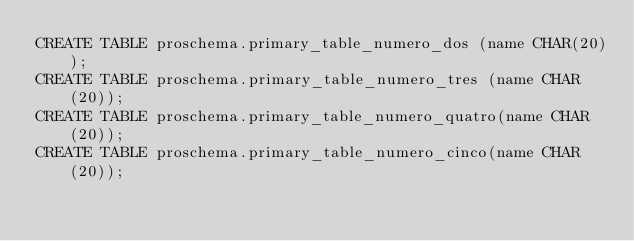<code> <loc_0><loc_0><loc_500><loc_500><_SQL_>CREATE TABLE proschema.primary_table_numero_dos (name CHAR(20));
CREATE TABLE proschema.primary_table_numero_tres (name CHAR(20));
CREATE TABLE proschema.primary_table_numero_quatro(name CHAR(20));
CREATE TABLE proschema.primary_table_numero_cinco(name CHAR(20));
</code> 